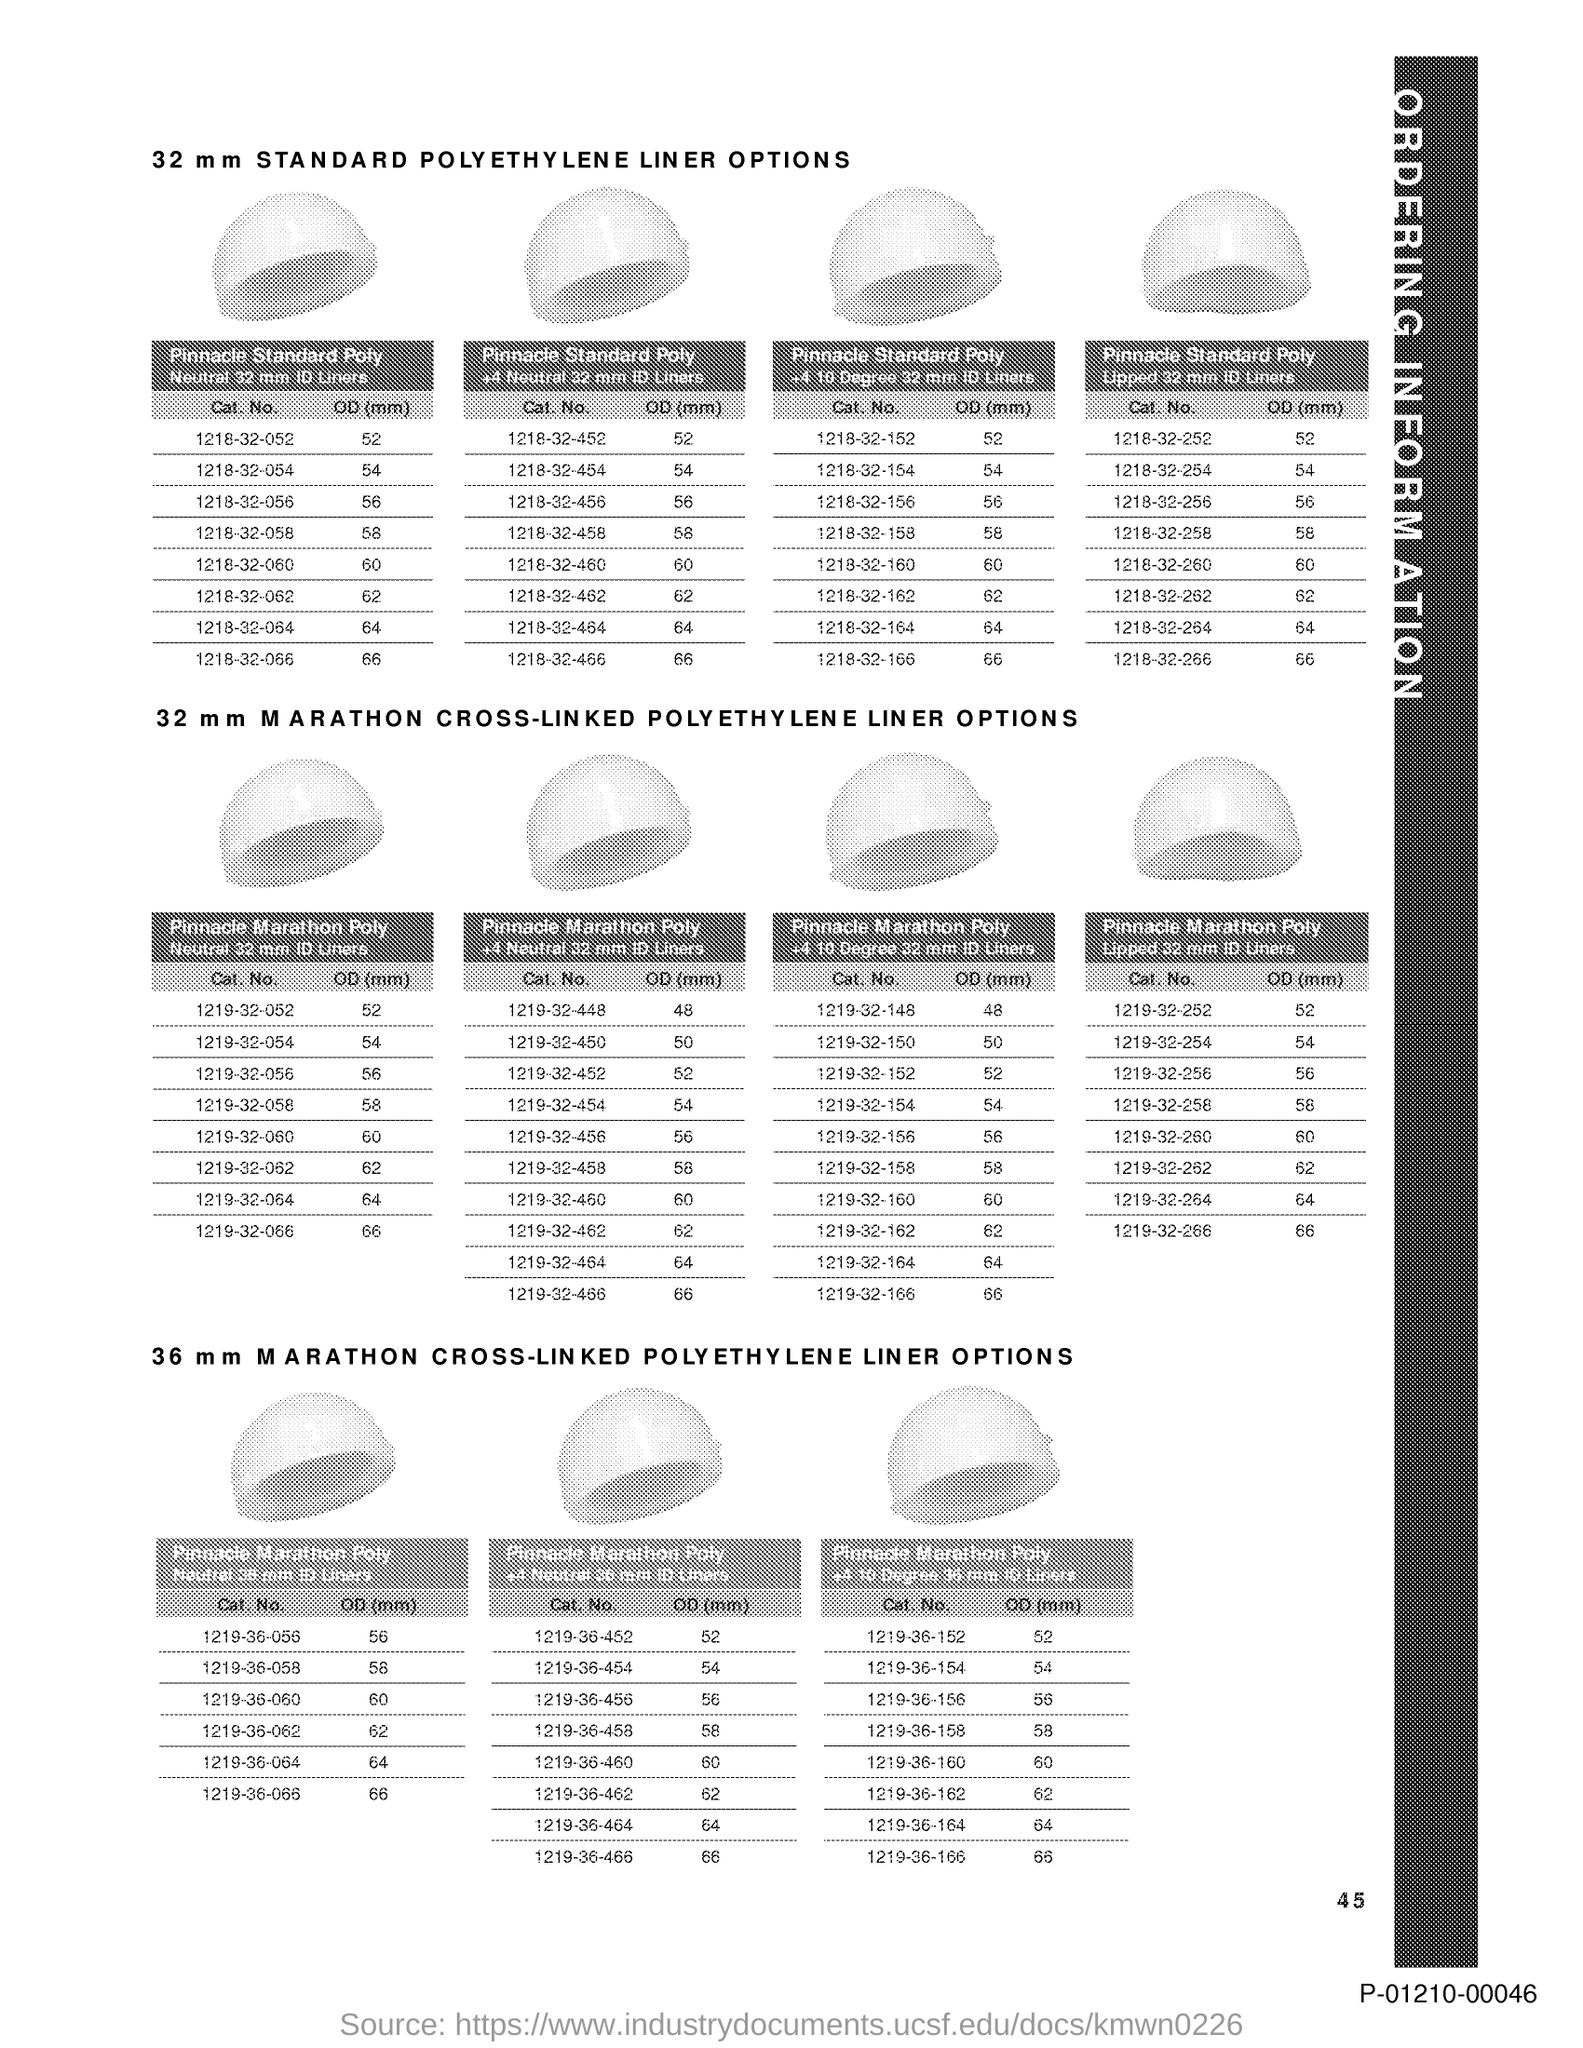What is the Page Number?
Provide a succinct answer. 45. 